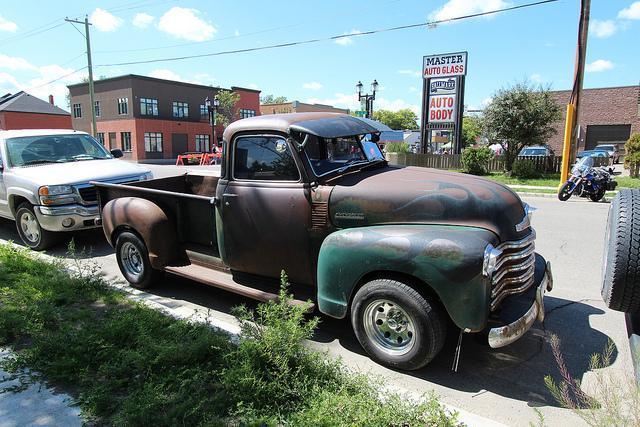How many trucks are in the photo?
Give a very brief answer. 2. 